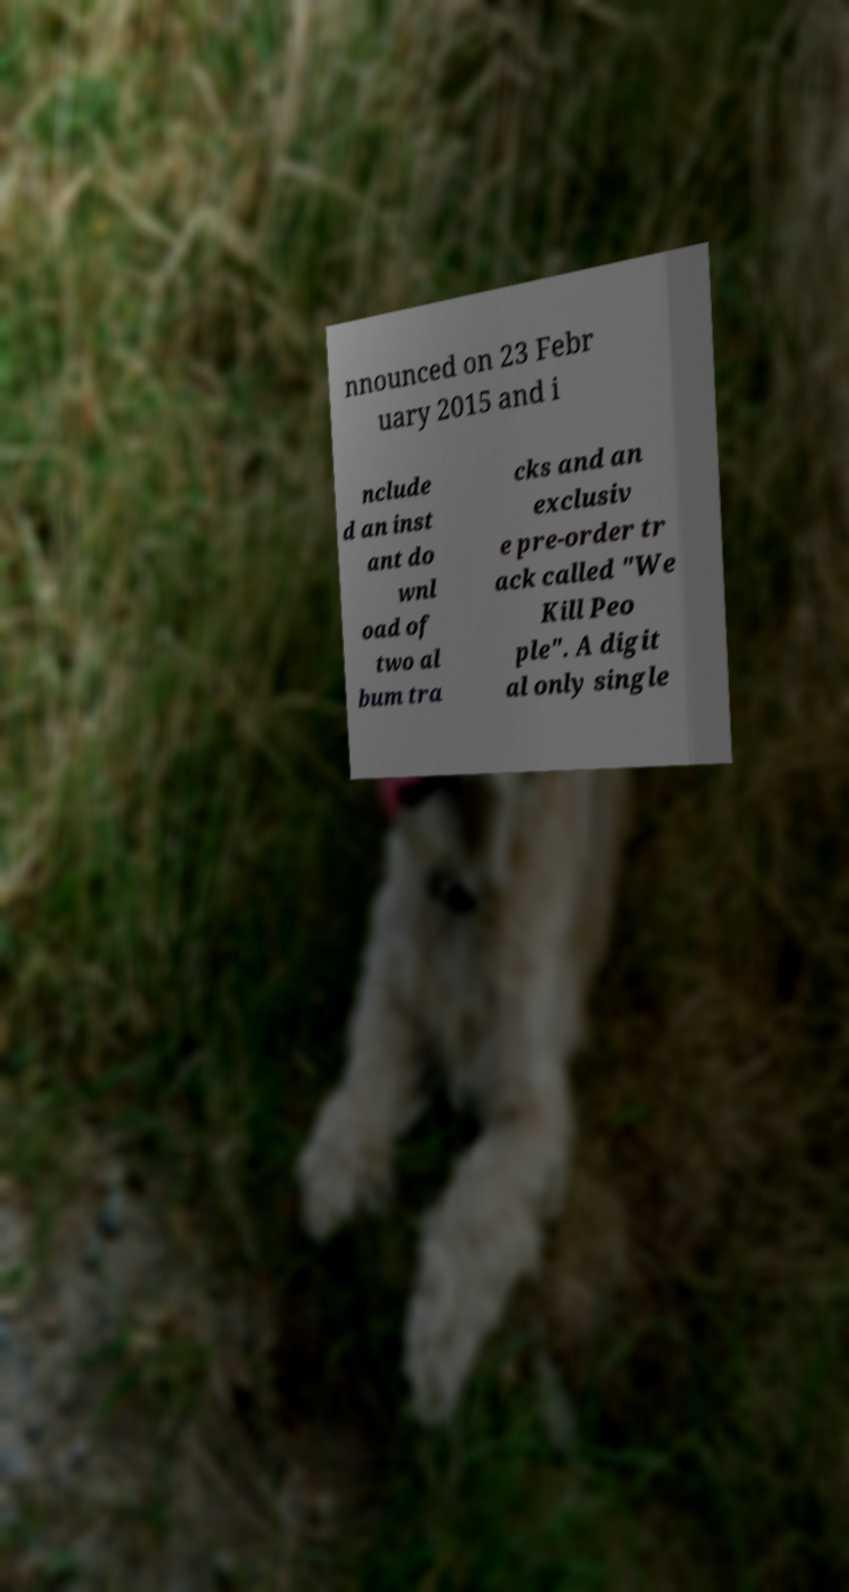Could you extract and type out the text from this image? nnounced on 23 Febr uary 2015 and i nclude d an inst ant do wnl oad of two al bum tra cks and an exclusiv e pre-order tr ack called "We Kill Peo ple". A digit al only single 